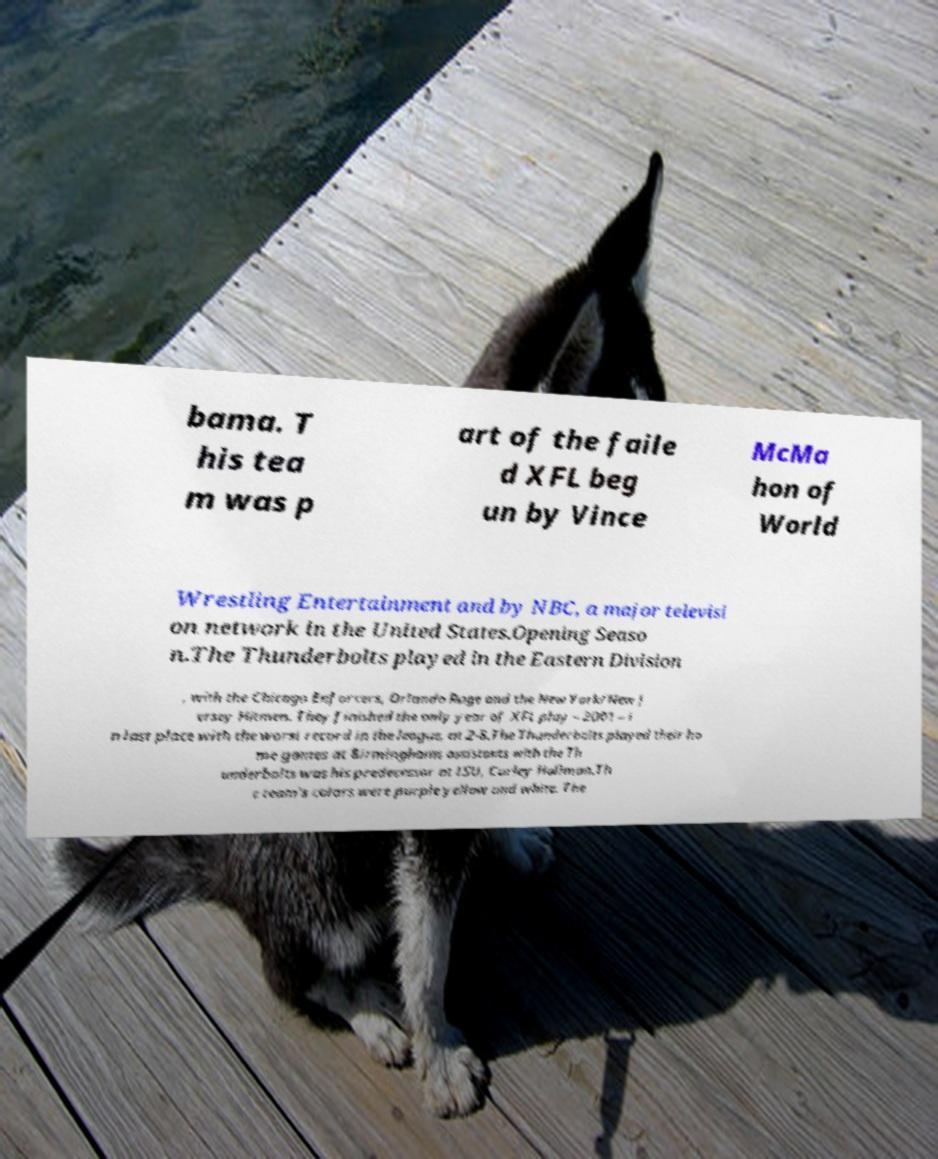There's text embedded in this image that I need extracted. Can you transcribe it verbatim? bama. T his tea m was p art of the faile d XFL beg un by Vince McMa hon of World Wrestling Entertainment and by NBC, a major televisi on network in the United States.Opening Seaso n.The Thunderbolts played in the Eastern Division , with the Chicago Enforcers, Orlando Rage and the New York/New J ersey Hitmen. They finished the only year of XFL play – 2001 – i n last place with the worst record in the league, at 2-8.The Thunderbolts played their ho me games at Birminghams assistants with the Th underbolts was his predecessor at LSU, Curley Hallman.Th e team's colors were purple yellow and white. The 